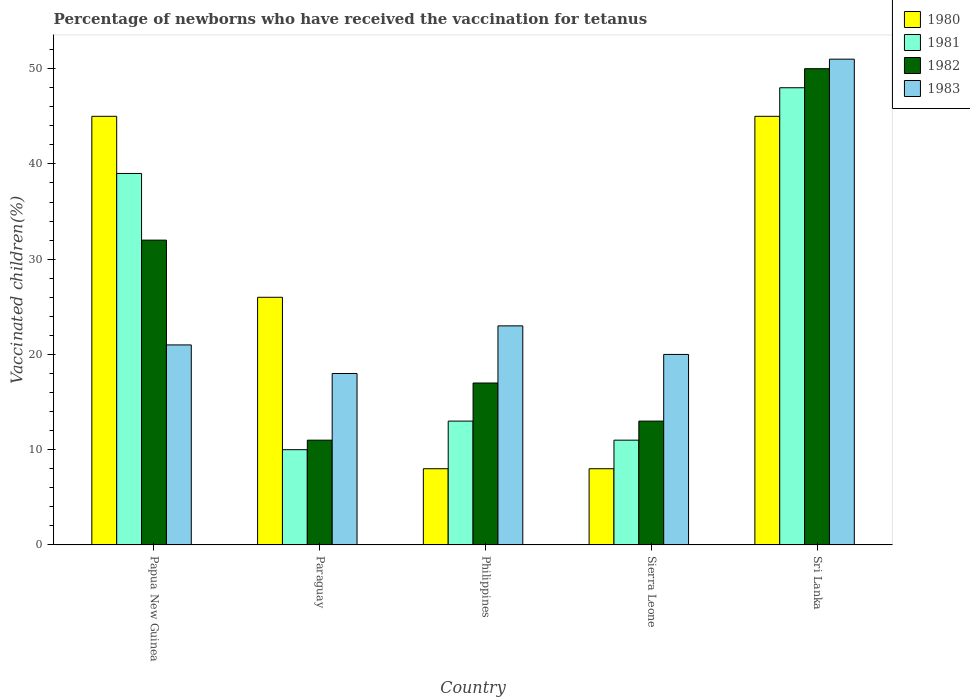Are the number of bars per tick equal to the number of legend labels?
Make the answer very short. Yes. Are the number of bars on each tick of the X-axis equal?
Give a very brief answer. Yes. How many bars are there on the 2nd tick from the right?
Offer a very short reply. 4. What is the label of the 5th group of bars from the left?
Your answer should be compact. Sri Lanka. In how many cases, is the number of bars for a given country not equal to the number of legend labels?
Your answer should be very brief. 0. What is the percentage of vaccinated children in 1980 in Philippines?
Ensure brevity in your answer.  8. Across all countries, what is the maximum percentage of vaccinated children in 1981?
Ensure brevity in your answer.  48. In which country was the percentage of vaccinated children in 1980 maximum?
Make the answer very short. Papua New Guinea. In which country was the percentage of vaccinated children in 1981 minimum?
Ensure brevity in your answer.  Paraguay. What is the total percentage of vaccinated children in 1983 in the graph?
Offer a very short reply. 133. What is the difference between the percentage of vaccinated children in 1980 in Sierra Leone and that in Sri Lanka?
Ensure brevity in your answer.  -37. What is the average percentage of vaccinated children in 1980 per country?
Keep it short and to the point. 26.4. What is the difference between the percentage of vaccinated children of/in 1981 and percentage of vaccinated children of/in 1982 in Paraguay?
Your response must be concise. -1. In how many countries, is the percentage of vaccinated children in 1982 greater than 42 %?
Give a very brief answer. 1. What is the ratio of the percentage of vaccinated children in 1981 in Paraguay to that in Philippines?
Provide a succinct answer. 0.77. In how many countries, is the percentage of vaccinated children in 1982 greater than the average percentage of vaccinated children in 1982 taken over all countries?
Provide a short and direct response. 2. Is the sum of the percentage of vaccinated children in 1982 in Papua New Guinea and Sri Lanka greater than the maximum percentage of vaccinated children in 1981 across all countries?
Your response must be concise. Yes. Is it the case that in every country, the sum of the percentage of vaccinated children in 1980 and percentage of vaccinated children in 1982 is greater than the sum of percentage of vaccinated children in 1983 and percentage of vaccinated children in 1981?
Keep it short and to the point. No. What does the 2nd bar from the left in Papua New Guinea represents?
Keep it short and to the point. 1981. How many bars are there?
Give a very brief answer. 20. Are all the bars in the graph horizontal?
Offer a very short reply. No. What is the difference between two consecutive major ticks on the Y-axis?
Make the answer very short. 10. Does the graph contain grids?
Provide a succinct answer. No. Where does the legend appear in the graph?
Make the answer very short. Top right. How are the legend labels stacked?
Your response must be concise. Vertical. What is the title of the graph?
Your answer should be very brief. Percentage of newborns who have received the vaccination for tetanus. What is the label or title of the X-axis?
Ensure brevity in your answer.  Country. What is the label or title of the Y-axis?
Provide a succinct answer. Vaccinated children(%). What is the Vaccinated children(%) in 1981 in Paraguay?
Your answer should be very brief. 10. What is the Vaccinated children(%) in 1983 in Paraguay?
Offer a terse response. 18. What is the Vaccinated children(%) in 1980 in Philippines?
Your answer should be compact. 8. What is the Vaccinated children(%) in 1983 in Philippines?
Offer a terse response. 23. What is the Vaccinated children(%) of 1981 in Sri Lanka?
Offer a terse response. 48. What is the Vaccinated children(%) of 1983 in Sri Lanka?
Offer a terse response. 51. Across all countries, what is the maximum Vaccinated children(%) of 1980?
Your response must be concise. 45. Across all countries, what is the maximum Vaccinated children(%) in 1981?
Make the answer very short. 48. Across all countries, what is the maximum Vaccinated children(%) in 1982?
Offer a terse response. 50. Across all countries, what is the minimum Vaccinated children(%) of 1980?
Give a very brief answer. 8. Across all countries, what is the minimum Vaccinated children(%) in 1981?
Your answer should be very brief. 10. Across all countries, what is the minimum Vaccinated children(%) of 1982?
Give a very brief answer. 11. What is the total Vaccinated children(%) in 1980 in the graph?
Offer a terse response. 132. What is the total Vaccinated children(%) in 1981 in the graph?
Ensure brevity in your answer.  121. What is the total Vaccinated children(%) in 1982 in the graph?
Keep it short and to the point. 123. What is the total Vaccinated children(%) of 1983 in the graph?
Keep it short and to the point. 133. What is the difference between the Vaccinated children(%) in 1980 in Papua New Guinea and that in Paraguay?
Offer a terse response. 19. What is the difference between the Vaccinated children(%) in 1980 in Papua New Guinea and that in Philippines?
Keep it short and to the point. 37. What is the difference between the Vaccinated children(%) of 1981 in Papua New Guinea and that in Philippines?
Ensure brevity in your answer.  26. What is the difference between the Vaccinated children(%) of 1982 in Papua New Guinea and that in Philippines?
Your response must be concise. 15. What is the difference between the Vaccinated children(%) of 1980 in Papua New Guinea and that in Sierra Leone?
Give a very brief answer. 37. What is the difference between the Vaccinated children(%) in 1981 in Papua New Guinea and that in Sierra Leone?
Offer a very short reply. 28. What is the difference between the Vaccinated children(%) of 1982 in Papua New Guinea and that in Sierra Leone?
Make the answer very short. 19. What is the difference between the Vaccinated children(%) of 1983 in Papua New Guinea and that in Sierra Leone?
Make the answer very short. 1. What is the difference between the Vaccinated children(%) of 1981 in Papua New Guinea and that in Sri Lanka?
Provide a short and direct response. -9. What is the difference between the Vaccinated children(%) of 1982 in Papua New Guinea and that in Sri Lanka?
Provide a succinct answer. -18. What is the difference between the Vaccinated children(%) of 1980 in Paraguay and that in Philippines?
Give a very brief answer. 18. What is the difference between the Vaccinated children(%) in 1981 in Paraguay and that in Philippines?
Offer a terse response. -3. What is the difference between the Vaccinated children(%) in 1983 in Paraguay and that in Philippines?
Ensure brevity in your answer.  -5. What is the difference between the Vaccinated children(%) of 1980 in Paraguay and that in Sierra Leone?
Your response must be concise. 18. What is the difference between the Vaccinated children(%) in 1981 in Paraguay and that in Sierra Leone?
Make the answer very short. -1. What is the difference between the Vaccinated children(%) of 1981 in Paraguay and that in Sri Lanka?
Your answer should be very brief. -38. What is the difference between the Vaccinated children(%) of 1982 in Paraguay and that in Sri Lanka?
Keep it short and to the point. -39. What is the difference between the Vaccinated children(%) in 1983 in Paraguay and that in Sri Lanka?
Offer a terse response. -33. What is the difference between the Vaccinated children(%) in 1980 in Philippines and that in Sierra Leone?
Keep it short and to the point. 0. What is the difference between the Vaccinated children(%) in 1982 in Philippines and that in Sierra Leone?
Keep it short and to the point. 4. What is the difference between the Vaccinated children(%) of 1980 in Philippines and that in Sri Lanka?
Offer a very short reply. -37. What is the difference between the Vaccinated children(%) of 1981 in Philippines and that in Sri Lanka?
Keep it short and to the point. -35. What is the difference between the Vaccinated children(%) in 1982 in Philippines and that in Sri Lanka?
Your answer should be compact. -33. What is the difference between the Vaccinated children(%) in 1983 in Philippines and that in Sri Lanka?
Your answer should be very brief. -28. What is the difference between the Vaccinated children(%) in 1980 in Sierra Leone and that in Sri Lanka?
Your answer should be very brief. -37. What is the difference between the Vaccinated children(%) in 1981 in Sierra Leone and that in Sri Lanka?
Your answer should be very brief. -37. What is the difference between the Vaccinated children(%) of 1982 in Sierra Leone and that in Sri Lanka?
Your response must be concise. -37. What is the difference between the Vaccinated children(%) in 1983 in Sierra Leone and that in Sri Lanka?
Offer a terse response. -31. What is the difference between the Vaccinated children(%) of 1981 in Papua New Guinea and the Vaccinated children(%) of 1982 in Paraguay?
Make the answer very short. 28. What is the difference between the Vaccinated children(%) in 1980 in Papua New Guinea and the Vaccinated children(%) in 1981 in Philippines?
Keep it short and to the point. 32. What is the difference between the Vaccinated children(%) in 1980 in Papua New Guinea and the Vaccinated children(%) in 1982 in Philippines?
Offer a terse response. 28. What is the difference between the Vaccinated children(%) of 1980 in Papua New Guinea and the Vaccinated children(%) of 1983 in Philippines?
Ensure brevity in your answer.  22. What is the difference between the Vaccinated children(%) in 1981 in Papua New Guinea and the Vaccinated children(%) in 1983 in Philippines?
Give a very brief answer. 16. What is the difference between the Vaccinated children(%) in 1982 in Papua New Guinea and the Vaccinated children(%) in 1983 in Philippines?
Offer a very short reply. 9. What is the difference between the Vaccinated children(%) of 1980 in Papua New Guinea and the Vaccinated children(%) of 1983 in Sierra Leone?
Your answer should be very brief. 25. What is the difference between the Vaccinated children(%) of 1981 in Papua New Guinea and the Vaccinated children(%) of 1982 in Sierra Leone?
Your answer should be compact. 26. What is the difference between the Vaccinated children(%) of 1980 in Papua New Guinea and the Vaccinated children(%) of 1982 in Sri Lanka?
Your answer should be very brief. -5. What is the difference between the Vaccinated children(%) of 1982 in Papua New Guinea and the Vaccinated children(%) of 1983 in Sri Lanka?
Offer a very short reply. -19. What is the difference between the Vaccinated children(%) in 1980 in Paraguay and the Vaccinated children(%) in 1982 in Philippines?
Ensure brevity in your answer.  9. What is the difference between the Vaccinated children(%) of 1980 in Paraguay and the Vaccinated children(%) of 1983 in Philippines?
Your answer should be compact. 3. What is the difference between the Vaccinated children(%) of 1981 in Paraguay and the Vaccinated children(%) of 1982 in Philippines?
Offer a very short reply. -7. What is the difference between the Vaccinated children(%) of 1981 in Paraguay and the Vaccinated children(%) of 1983 in Philippines?
Your response must be concise. -13. What is the difference between the Vaccinated children(%) in 1980 in Paraguay and the Vaccinated children(%) in 1981 in Sierra Leone?
Provide a succinct answer. 15. What is the difference between the Vaccinated children(%) of 1980 in Paraguay and the Vaccinated children(%) of 1982 in Sierra Leone?
Offer a terse response. 13. What is the difference between the Vaccinated children(%) of 1980 in Paraguay and the Vaccinated children(%) of 1983 in Sierra Leone?
Offer a very short reply. 6. What is the difference between the Vaccinated children(%) of 1981 in Paraguay and the Vaccinated children(%) of 1982 in Sierra Leone?
Your answer should be compact. -3. What is the difference between the Vaccinated children(%) in 1980 in Paraguay and the Vaccinated children(%) in 1981 in Sri Lanka?
Keep it short and to the point. -22. What is the difference between the Vaccinated children(%) in 1981 in Paraguay and the Vaccinated children(%) in 1982 in Sri Lanka?
Make the answer very short. -40. What is the difference between the Vaccinated children(%) in 1981 in Paraguay and the Vaccinated children(%) in 1983 in Sri Lanka?
Provide a succinct answer. -41. What is the difference between the Vaccinated children(%) of 1982 in Paraguay and the Vaccinated children(%) of 1983 in Sri Lanka?
Provide a succinct answer. -40. What is the difference between the Vaccinated children(%) of 1981 in Philippines and the Vaccinated children(%) of 1982 in Sierra Leone?
Ensure brevity in your answer.  0. What is the difference between the Vaccinated children(%) in 1982 in Philippines and the Vaccinated children(%) in 1983 in Sierra Leone?
Your answer should be very brief. -3. What is the difference between the Vaccinated children(%) of 1980 in Philippines and the Vaccinated children(%) of 1981 in Sri Lanka?
Give a very brief answer. -40. What is the difference between the Vaccinated children(%) of 1980 in Philippines and the Vaccinated children(%) of 1982 in Sri Lanka?
Offer a terse response. -42. What is the difference between the Vaccinated children(%) of 1980 in Philippines and the Vaccinated children(%) of 1983 in Sri Lanka?
Offer a very short reply. -43. What is the difference between the Vaccinated children(%) in 1981 in Philippines and the Vaccinated children(%) in 1982 in Sri Lanka?
Provide a succinct answer. -37. What is the difference between the Vaccinated children(%) of 1981 in Philippines and the Vaccinated children(%) of 1983 in Sri Lanka?
Give a very brief answer. -38. What is the difference between the Vaccinated children(%) of 1982 in Philippines and the Vaccinated children(%) of 1983 in Sri Lanka?
Make the answer very short. -34. What is the difference between the Vaccinated children(%) of 1980 in Sierra Leone and the Vaccinated children(%) of 1981 in Sri Lanka?
Provide a short and direct response. -40. What is the difference between the Vaccinated children(%) of 1980 in Sierra Leone and the Vaccinated children(%) of 1982 in Sri Lanka?
Your answer should be very brief. -42. What is the difference between the Vaccinated children(%) in 1980 in Sierra Leone and the Vaccinated children(%) in 1983 in Sri Lanka?
Give a very brief answer. -43. What is the difference between the Vaccinated children(%) in 1981 in Sierra Leone and the Vaccinated children(%) in 1982 in Sri Lanka?
Ensure brevity in your answer.  -39. What is the difference between the Vaccinated children(%) in 1981 in Sierra Leone and the Vaccinated children(%) in 1983 in Sri Lanka?
Ensure brevity in your answer.  -40. What is the difference between the Vaccinated children(%) in 1982 in Sierra Leone and the Vaccinated children(%) in 1983 in Sri Lanka?
Ensure brevity in your answer.  -38. What is the average Vaccinated children(%) of 1980 per country?
Your answer should be compact. 26.4. What is the average Vaccinated children(%) in 1981 per country?
Make the answer very short. 24.2. What is the average Vaccinated children(%) in 1982 per country?
Offer a terse response. 24.6. What is the average Vaccinated children(%) of 1983 per country?
Offer a very short reply. 26.6. What is the difference between the Vaccinated children(%) in 1980 and Vaccinated children(%) in 1982 in Papua New Guinea?
Make the answer very short. 13. What is the difference between the Vaccinated children(%) of 1980 and Vaccinated children(%) of 1983 in Papua New Guinea?
Offer a very short reply. 24. What is the difference between the Vaccinated children(%) in 1981 and Vaccinated children(%) in 1982 in Papua New Guinea?
Your response must be concise. 7. What is the difference between the Vaccinated children(%) of 1981 and Vaccinated children(%) of 1983 in Papua New Guinea?
Offer a terse response. 18. What is the difference between the Vaccinated children(%) in 1982 and Vaccinated children(%) in 1983 in Papua New Guinea?
Your answer should be compact. 11. What is the difference between the Vaccinated children(%) in 1980 and Vaccinated children(%) in 1981 in Paraguay?
Offer a very short reply. 16. What is the difference between the Vaccinated children(%) of 1980 and Vaccinated children(%) of 1982 in Paraguay?
Give a very brief answer. 15. What is the difference between the Vaccinated children(%) in 1981 and Vaccinated children(%) in 1983 in Paraguay?
Your response must be concise. -8. What is the difference between the Vaccinated children(%) in 1980 and Vaccinated children(%) in 1982 in Philippines?
Ensure brevity in your answer.  -9. What is the difference between the Vaccinated children(%) of 1980 and Vaccinated children(%) of 1983 in Philippines?
Give a very brief answer. -15. What is the difference between the Vaccinated children(%) of 1981 and Vaccinated children(%) of 1982 in Philippines?
Your response must be concise. -4. What is the difference between the Vaccinated children(%) of 1982 and Vaccinated children(%) of 1983 in Philippines?
Your response must be concise. -6. What is the difference between the Vaccinated children(%) of 1980 and Vaccinated children(%) of 1983 in Sierra Leone?
Your answer should be very brief. -12. What is the difference between the Vaccinated children(%) in 1981 and Vaccinated children(%) in 1982 in Sierra Leone?
Provide a short and direct response. -2. What is the difference between the Vaccinated children(%) in 1981 and Vaccinated children(%) in 1983 in Sierra Leone?
Your answer should be very brief. -9. What is the difference between the Vaccinated children(%) of 1982 and Vaccinated children(%) of 1983 in Sierra Leone?
Your answer should be very brief. -7. What is the difference between the Vaccinated children(%) in 1980 and Vaccinated children(%) in 1983 in Sri Lanka?
Offer a terse response. -6. What is the difference between the Vaccinated children(%) in 1982 and Vaccinated children(%) in 1983 in Sri Lanka?
Give a very brief answer. -1. What is the ratio of the Vaccinated children(%) in 1980 in Papua New Guinea to that in Paraguay?
Offer a very short reply. 1.73. What is the ratio of the Vaccinated children(%) in 1981 in Papua New Guinea to that in Paraguay?
Provide a succinct answer. 3.9. What is the ratio of the Vaccinated children(%) of 1982 in Papua New Guinea to that in Paraguay?
Your response must be concise. 2.91. What is the ratio of the Vaccinated children(%) of 1980 in Papua New Guinea to that in Philippines?
Your answer should be compact. 5.62. What is the ratio of the Vaccinated children(%) of 1981 in Papua New Guinea to that in Philippines?
Your answer should be compact. 3. What is the ratio of the Vaccinated children(%) in 1982 in Papua New Guinea to that in Philippines?
Ensure brevity in your answer.  1.88. What is the ratio of the Vaccinated children(%) in 1980 in Papua New Guinea to that in Sierra Leone?
Provide a succinct answer. 5.62. What is the ratio of the Vaccinated children(%) of 1981 in Papua New Guinea to that in Sierra Leone?
Make the answer very short. 3.55. What is the ratio of the Vaccinated children(%) in 1982 in Papua New Guinea to that in Sierra Leone?
Provide a short and direct response. 2.46. What is the ratio of the Vaccinated children(%) in 1983 in Papua New Guinea to that in Sierra Leone?
Ensure brevity in your answer.  1.05. What is the ratio of the Vaccinated children(%) in 1981 in Papua New Guinea to that in Sri Lanka?
Keep it short and to the point. 0.81. What is the ratio of the Vaccinated children(%) of 1982 in Papua New Guinea to that in Sri Lanka?
Give a very brief answer. 0.64. What is the ratio of the Vaccinated children(%) of 1983 in Papua New Guinea to that in Sri Lanka?
Make the answer very short. 0.41. What is the ratio of the Vaccinated children(%) of 1981 in Paraguay to that in Philippines?
Your response must be concise. 0.77. What is the ratio of the Vaccinated children(%) in 1982 in Paraguay to that in Philippines?
Keep it short and to the point. 0.65. What is the ratio of the Vaccinated children(%) of 1983 in Paraguay to that in Philippines?
Provide a short and direct response. 0.78. What is the ratio of the Vaccinated children(%) in 1981 in Paraguay to that in Sierra Leone?
Provide a succinct answer. 0.91. What is the ratio of the Vaccinated children(%) of 1982 in Paraguay to that in Sierra Leone?
Give a very brief answer. 0.85. What is the ratio of the Vaccinated children(%) of 1980 in Paraguay to that in Sri Lanka?
Give a very brief answer. 0.58. What is the ratio of the Vaccinated children(%) in 1981 in Paraguay to that in Sri Lanka?
Offer a terse response. 0.21. What is the ratio of the Vaccinated children(%) of 1982 in Paraguay to that in Sri Lanka?
Offer a terse response. 0.22. What is the ratio of the Vaccinated children(%) in 1983 in Paraguay to that in Sri Lanka?
Keep it short and to the point. 0.35. What is the ratio of the Vaccinated children(%) in 1981 in Philippines to that in Sierra Leone?
Provide a succinct answer. 1.18. What is the ratio of the Vaccinated children(%) of 1982 in Philippines to that in Sierra Leone?
Keep it short and to the point. 1.31. What is the ratio of the Vaccinated children(%) in 1983 in Philippines to that in Sierra Leone?
Ensure brevity in your answer.  1.15. What is the ratio of the Vaccinated children(%) in 1980 in Philippines to that in Sri Lanka?
Give a very brief answer. 0.18. What is the ratio of the Vaccinated children(%) in 1981 in Philippines to that in Sri Lanka?
Offer a terse response. 0.27. What is the ratio of the Vaccinated children(%) in 1982 in Philippines to that in Sri Lanka?
Make the answer very short. 0.34. What is the ratio of the Vaccinated children(%) in 1983 in Philippines to that in Sri Lanka?
Your response must be concise. 0.45. What is the ratio of the Vaccinated children(%) in 1980 in Sierra Leone to that in Sri Lanka?
Offer a terse response. 0.18. What is the ratio of the Vaccinated children(%) in 1981 in Sierra Leone to that in Sri Lanka?
Offer a terse response. 0.23. What is the ratio of the Vaccinated children(%) in 1982 in Sierra Leone to that in Sri Lanka?
Provide a short and direct response. 0.26. What is the ratio of the Vaccinated children(%) of 1983 in Sierra Leone to that in Sri Lanka?
Your answer should be very brief. 0.39. What is the difference between the highest and the second highest Vaccinated children(%) of 1980?
Give a very brief answer. 0. What is the difference between the highest and the lowest Vaccinated children(%) of 1981?
Provide a short and direct response. 38. What is the difference between the highest and the lowest Vaccinated children(%) of 1982?
Offer a very short reply. 39. What is the difference between the highest and the lowest Vaccinated children(%) of 1983?
Make the answer very short. 33. 